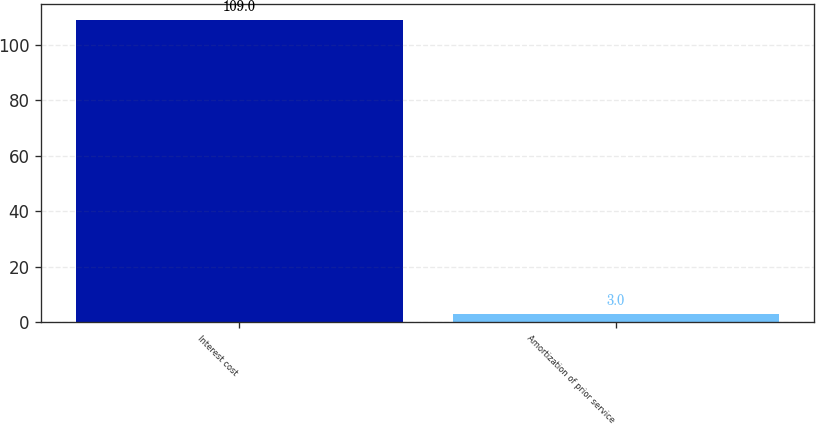<chart> <loc_0><loc_0><loc_500><loc_500><bar_chart><fcel>Interest cost<fcel>Amortization of prior service<nl><fcel>109<fcel>3<nl></chart> 